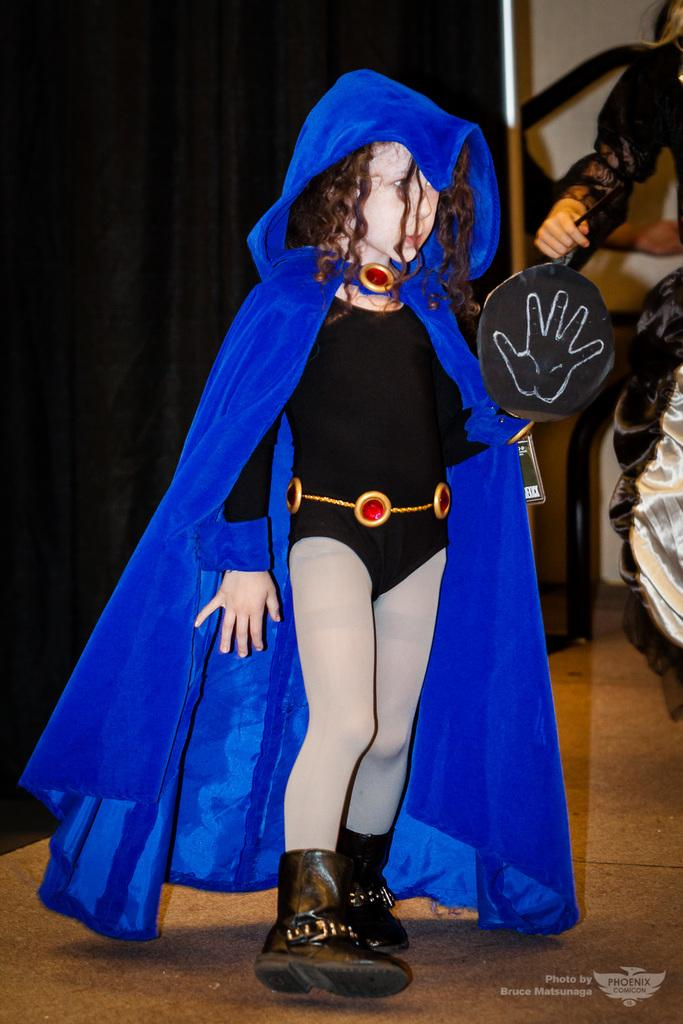What is the main subject of the image? There is a child in the image. What is the child wearing? The child is wearing a costume. Where is the child standing? The child is standing on the floor. What can be seen in the background of the image? There is a curtain in the background of the image. What type of prison can be seen in the background of the image? There is no prison present in the image; it features a child wearing a costume and standing on the floor with a curtain in the background. What invention is the child holding in the image? There is no invention visible in the image; the child is simply wearing a costume and standing on the floor. 